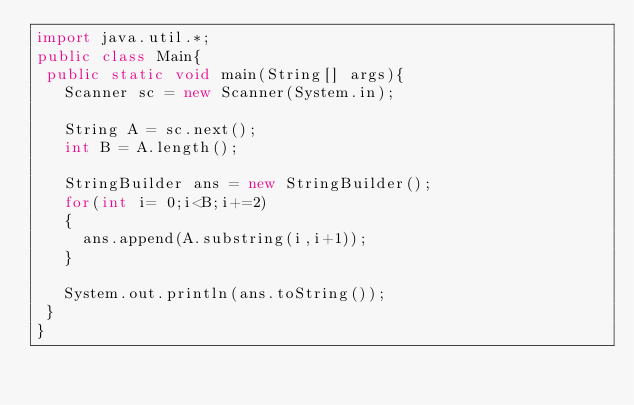<code> <loc_0><loc_0><loc_500><loc_500><_Java_>import java.util.*;
public class Main{
 public static void main(String[] args){
   Scanner sc = new Scanner(System.in);
 
   String A = sc.next();
   int B = A.length();
 
   StringBuilder ans = new StringBuilder();
   for(int i= 0;i<B;i+=2)
   {
     ans.append(A.substring(i,i+1));
   }
 
   System.out.println(ans.toString());
 }
}</code> 